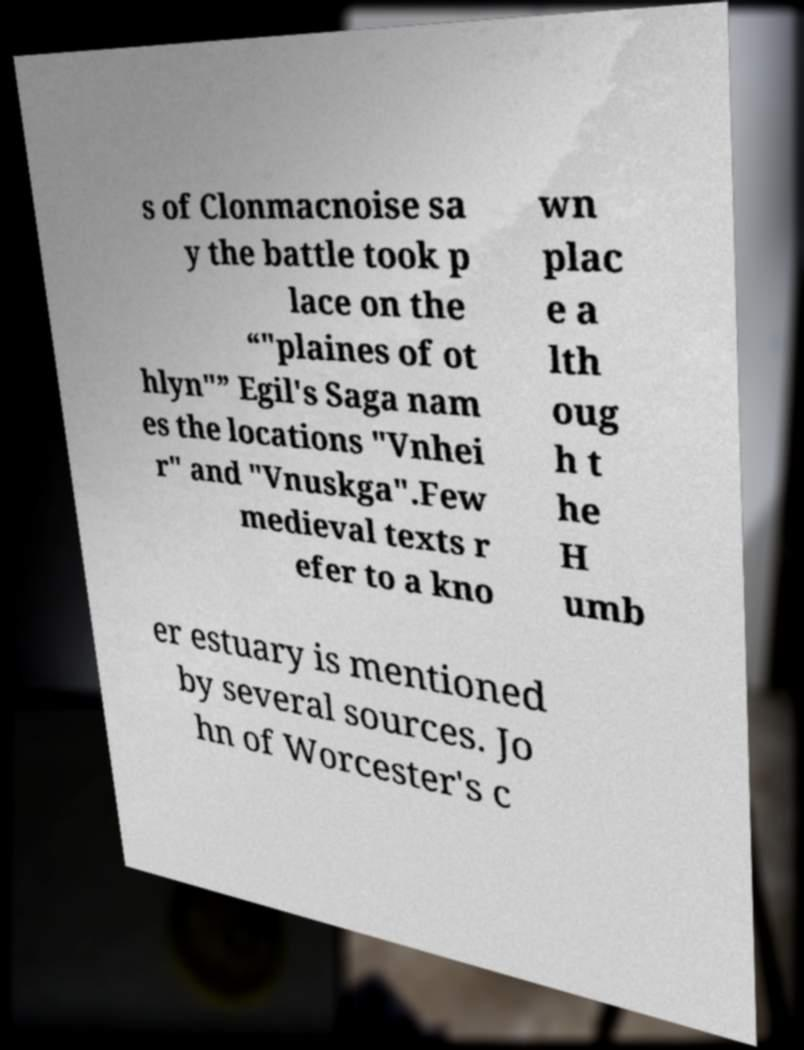Could you assist in decoding the text presented in this image and type it out clearly? s of Clonmacnoise sa y the battle took p lace on the “"plaines of ot hlyn"” Egil's Saga nam es the locations "Vnhei r" and "Vnuskga".Few medieval texts r efer to a kno wn plac e a lth oug h t he H umb er estuary is mentioned by several sources. Jo hn of Worcester's c 